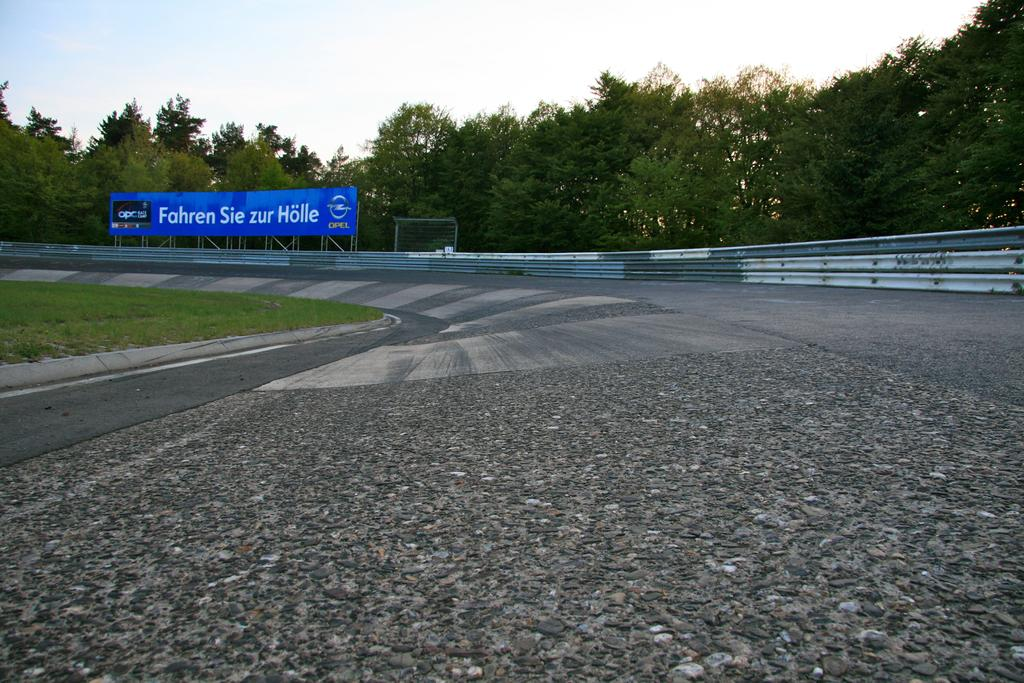<image>
Write a terse but informative summary of the picture. A blue sign on the side of a race track reads Fahren Sie zur Holle. 